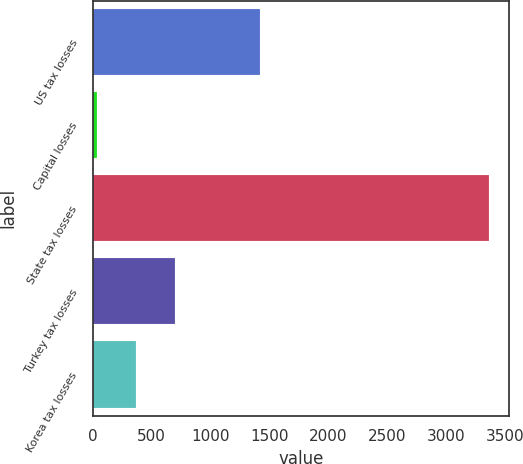<chart> <loc_0><loc_0><loc_500><loc_500><bar_chart><fcel>US tax losses<fcel>Capital losses<fcel>State tax losses<fcel>Turkey tax losses<fcel>Korea tax losses<nl><fcel>1422<fcel>36<fcel>3367<fcel>702.2<fcel>369.1<nl></chart> 